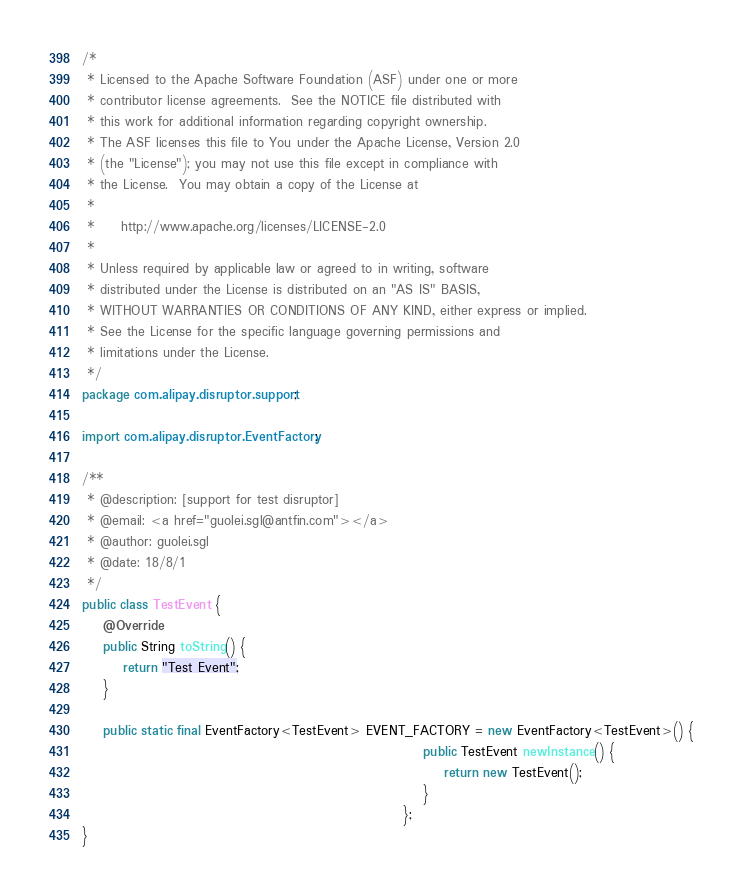Convert code to text. <code><loc_0><loc_0><loc_500><loc_500><_Java_>/*
 * Licensed to the Apache Software Foundation (ASF) under one or more
 * contributor license agreements.  See the NOTICE file distributed with
 * this work for additional information regarding copyright ownership.
 * The ASF licenses this file to You under the Apache License, Version 2.0
 * (the "License"); you may not use this file except in compliance with
 * the License.  You may obtain a copy of the License at
 *
 *     http://www.apache.org/licenses/LICENSE-2.0
 *
 * Unless required by applicable law or agreed to in writing, software
 * distributed under the License is distributed on an "AS IS" BASIS,
 * WITHOUT WARRANTIES OR CONDITIONS OF ANY KIND, either express or implied.
 * See the License for the specific language governing permissions and
 * limitations under the License.
 */
package com.alipay.disruptor.support;

import com.alipay.disruptor.EventFactory;

/**
 * @description: [support for test disruptor]
 * @email: <a href="guolei.sgl@antfin.com"></a>
 * @author: guolei.sgl
 * @date: 18/8/1
 */
public class TestEvent {
    @Override
    public String toString() {
        return "Test Event";
    }

    public static final EventFactory<TestEvent> EVENT_FACTORY = new EventFactory<TestEvent>() {
                                                                  public TestEvent newInstance() {
                                                                      return new TestEvent();
                                                                  }
                                                              };
}
</code> 